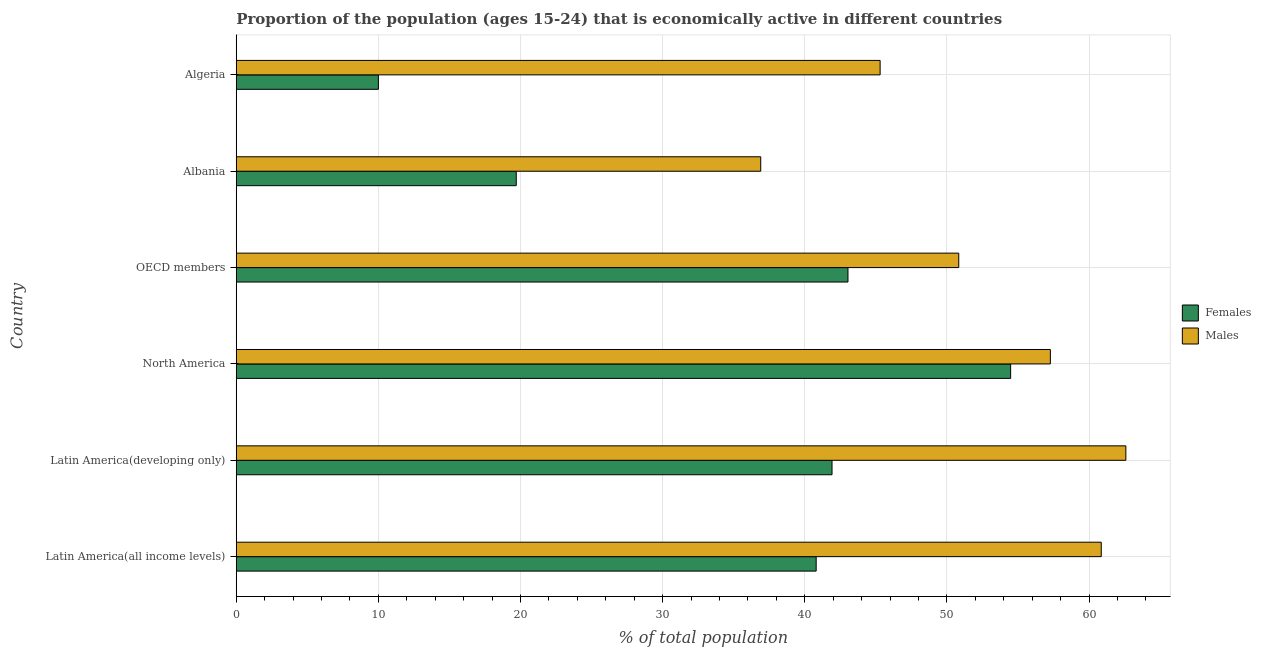How many different coloured bars are there?
Your answer should be very brief. 2. Are the number of bars per tick equal to the number of legend labels?
Your answer should be compact. Yes. How many bars are there on the 4th tick from the top?
Keep it short and to the point. 2. What is the label of the 6th group of bars from the top?
Make the answer very short. Latin America(all income levels). In how many cases, is the number of bars for a given country not equal to the number of legend labels?
Your answer should be compact. 0. What is the percentage of economically active female population in Latin America(developing only)?
Make the answer very short. 41.92. Across all countries, what is the maximum percentage of economically active female population?
Keep it short and to the point. 54.48. Across all countries, what is the minimum percentage of economically active female population?
Keep it short and to the point. 10. In which country was the percentage of economically active female population minimum?
Give a very brief answer. Algeria. What is the total percentage of economically active male population in the graph?
Offer a terse response. 313.76. What is the difference between the percentage of economically active female population in Algeria and that in OECD members?
Your answer should be compact. -33.04. What is the difference between the percentage of economically active male population in Latin America(developing only) and the percentage of economically active female population in North America?
Your answer should be very brief. 8.11. What is the average percentage of economically active female population per country?
Give a very brief answer. 34.99. What is the difference between the percentage of economically active female population and percentage of economically active male population in Latin America(all income levels)?
Make the answer very short. -20.06. What is the ratio of the percentage of economically active male population in Latin America(all income levels) to that in OECD members?
Keep it short and to the point. 1.2. Is the percentage of economically active male population in North America less than that in OECD members?
Your answer should be compact. No. What is the difference between the highest and the second highest percentage of economically active female population?
Offer a very short reply. 11.45. What is the difference between the highest and the lowest percentage of economically active female population?
Ensure brevity in your answer.  44.48. What does the 1st bar from the top in North America represents?
Your answer should be compact. Males. What does the 1st bar from the bottom in OECD members represents?
Keep it short and to the point. Females. Are all the bars in the graph horizontal?
Offer a terse response. Yes. What is the difference between two consecutive major ticks on the X-axis?
Your response must be concise. 10. Does the graph contain any zero values?
Your response must be concise. No. How many legend labels are there?
Provide a short and direct response. 2. How are the legend labels stacked?
Make the answer very short. Vertical. What is the title of the graph?
Offer a very short reply. Proportion of the population (ages 15-24) that is economically active in different countries. Does "US$" appear as one of the legend labels in the graph?
Your answer should be very brief. No. What is the label or title of the X-axis?
Provide a short and direct response. % of total population. What is the label or title of the Y-axis?
Make the answer very short. Country. What is the % of total population in Females in Latin America(all income levels)?
Offer a very short reply. 40.8. What is the % of total population of Males in Latin America(all income levels)?
Your response must be concise. 60.86. What is the % of total population in Females in Latin America(developing only)?
Make the answer very short. 41.92. What is the % of total population in Males in Latin America(developing only)?
Make the answer very short. 62.59. What is the % of total population in Females in North America?
Your answer should be very brief. 54.48. What is the % of total population in Males in North America?
Give a very brief answer. 57.28. What is the % of total population of Females in OECD members?
Your answer should be very brief. 43.04. What is the % of total population of Males in OECD members?
Your response must be concise. 50.83. What is the % of total population in Females in Albania?
Make the answer very short. 19.7. What is the % of total population in Males in Albania?
Your response must be concise. 36.9. What is the % of total population in Males in Algeria?
Give a very brief answer. 45.3. Across all countries, what is the maximum % of total population in Females?
Your response must be concise. 54.48. Across all countries, what is the maximum % of total population of Males?
Your answer should be compact. 62.59. Across all countries, what is the minimum % of total population of Females?
Keep it short and to the point. 10. Across all countries, what is the minimum % of total population of Males?
Provide a short and direct response. 36.9. What is the total % of total population in Females in the graph?
Keep it short and to the point. 209.94. What is the total % of total population in Males in the graph?
Your answer should be very brief. 313.76. What is the difference between the % of total population in Females in Latin America(all income levels) and that in Latin America(developing only)?
Provide a succinct answer. -1.12. What is the difference between the % of total population in Males in Latin America(all income levels) and that in Latin America(developing only)?
Provide a succinct answer. -1.73. What is the difference between the % of total population of Females in Latin America(all income levels) and that in North America?
Make the answer very short. -13.68. What is the difference between the % of total population of Males in Latin America(all income levels) and that in North America?
Your answer should be very brief. 3.58. What is the difference between the % of total population in Females in Latin America(all income levels) and that in OECD members?
Offer a very short reply. -2.24. What is the difference between the % of total population of Males in Latin America(all income levels) and that in OECD members?
Your answer should be compact. 10.03. What is the difference between the % of total population in Females in Latin America(all income levels) and that in Albania?
Keep it short and to the point. 21.1. What is the difference between the % of total population in Males in Latin America(all income levels) and that in Albania?
Keep it short and to the point. 23.96. What is the difference between the % of total population in Females in Latin America(all income levels) and that in Algeria?
Make the answer very short. 30.8. What is the difference between the % of total population in Males in Latin America(all income levels) and that in Algeria?
Provide a short and direct response. 15.56. What is the difference between the % of total population of Females in Latin America(developing only) and that in North America?
Your answer should be very brief. -12.57. What is the difference between the % of total population in Males in Latin America(developing only) and that in North America?
Make the answer very short. 5.31. What is the difference between the % of total population of Females in Latin America(developing only) and that in OECD members?
Your response must be concise. -1.12. What is the difference between the % of total population of Males in Latin America(developing only) and that in OECD members?
Provide a succinct answer. 11.76. What is the difference between the % of total population in Females in Latin America(developing only) and that in Albania?
Keep it short and to the point. 22.22. What is the difference between the % of total population of Males in Latin America(developing only) and that in Albania?
Your answer should be compact. 25.69. What is the difference between the % of total population in Females in Latin America(developing only) and that in Algeria?
Provide a short and direct response. 31.92. What is the difference between the % of total population of Males in Latin America(developing only) and that in Algeria?
Your answer should be compact. 17.29. What is the difference between the % of total population of Females in North America and that in OECD members?
Keep it short and to the point. 11.45. What is the difference between the % of total population of Males in North America and that in OECD members?
Keep it short and to the point. 6.45. What is the difference between the % of total population of Females in North America and that in Albania?
Keep it short and to the point. 34.78. What is the difference between the % of total population in Males in North America and that in Albania?
Provide a short and direct response. 20.38. What is the difference between the % of total population of Females in North America and that in Algeria?
Make the answer very short. 44.48. What is the difference between the % of total population in Males in North America and that in Algeria?
Ensure brevity in your answer.  11.98. What is the difference between the % of total population in Females in OECD members and that in Albania?
Give a very brief answer. 23.34. What is the difference between the % of total population of Males in OECD members and that in Albania?
Your answer should be compact. 13.93. What is the difference between the % of total population of Females in OECD members and that in Algeria?
Ensure brevity in your answer.  33.04. What is the difference between the % of total population in Males in OECD members and that in Algeria?
Offer a terse response. 5.53. What is the difference between the % of total population of Females in Albania and that in Algeria?
Provide a short and direct response. 9.7. What is the difference between the % of total population in Males in Albania and that in Algeria?
Keep it short and to the point. -8.4. What is the difference between the % of total population of Females in Latin America(all income levels) and the % of total population of Males in Latin America(developing only)?
Your answer should be very brief. -21.79. What is the difference between the % of total population in Females in Latin America(all income levels) and the % of total population in Males in North America?
Your answer should be very brief. -16.48. What is the difference between the % of total population of Females in Latin America(all income levels) and the % of total population of Males in OECD members?
Offer a very short reply. -10.03. What is the difference between the % of total population of Females in Latin America(all income levels) and the % of total population of Males in Albania?
Make the answer very short. 3.9. What is the difference between the % of total population of Females in Latin America(all income levels) and the % of total population of Males in Algeria?
Keep it short and to the point. -4.5. What is the difference between the % of total population in Females in Latin America(developing only) and the % of total population in Males in North America?
Offer a very short reply. -15.36. What is the difference between the % of total population in Females in Latin America(developing only) and the % of total population in Males in OECD members?
Keep it short and to the point. -8.92. What is the difference between the % of total population in Females in Latin America(developing only) and the % of total population in Males in Albania?
Your response must be concise. 5.02. What is the difference between the % of total population in Females in Latin America(developing only) and the % of total population in Males in Algeria?
Keep it short and to the point. -3.38. What is the difference between the % of total population of Females in North America and the % of total population of Males in OECD members?
Your answer should be very brief. 3.65. What is the difference between the % of total population of Females in North America and the % of total population of Males in Albania?
Ensure brevity in your answer.  17.58. What is the difference between the % of total population of Females in North America and the % of total population of Males in Algeria?
Your answer should be compact. 9.18. What is the difference between the % of total population of Females in OECD members and the % of total population of Males in Albania?
Provide a short and direct response. 6.14. What is the difference between the % of total population of Females in OECD members and the % of total population of Males in Algeria?
Your answer should be very brief. -2.26. What is the difference between the % of total population in Females in Albania and the % of total population in Males in Algeria?
Your answer should be compact. -25.6. What is the average % of total population in Females per country?
Provide a short and direct response. 34.99. What is the average % of total population of Males per country?
Offer a terse response. 52.29. What is the difference between the % of total population in Females and % of total population in Males in Latin America(all income levels)?
Your answer should be compact. -20.06. What is the difference between the % of total population of Females and % of total population of Males in Latin America(developing only)?
Ensure brevity in your answer.  -20.67. What is the difference between the % of total population of Females and % of total population of Males in North America?
Ensure brevity in your answer.  -2.79. What is the difference between the % of total population of Females and % of total population of Males in OECD members?
Keep it short and to the point. -7.79. What is the difference between the % of total population of Females and % of total population of Males in Albania?
Provide a succinct answer. -17.2. What is the difference between the % of total population in Females and % of total population in Males in Algeria?
Offer a terse response. -35.3. What is the ratio of the % of total population of Females in Latin America(all income levels) to that in Latin America(developing only)?
Offer a terse response. 0.97. What is the ratio of the % of total population in Males in Latin America(all income levels) to that in Latin America(developing only)?
Offer a very short reply. 0.97. What is the ratio of the % of total population of Females in Latin America(all income levels) to that in North America?
Make the answer very short. 0.75. What is the ratio of the % of total population of Males in Latin America(all income levels) to that in North America?
Provide a succinct answer. 1.06. What is the ratio of the % of total population of Females in Latin America(all income levels) to that in OECD members?
Give a very brief answer. 0.95. What is the ratio of the % of total population in Males in Latin America(all income levels) to that in OECD members?
Provide a short and direct response. 1.2. What is the ratio of the % of total population in Females in Latin America(all income levels) to that in Albania?
Offer a very short reply. 2.07. What is the ratio of the % of total population in Males in Latin America(all income levels) to that in Albania?
Provide a short and direct response. 1.65. What is the ratio of the % of total population in Females in Latin America(all income levels) to that in Algeria?
Provide a short and direct response. 4.08. What is the ratio of the % of total population of Males in Latin America(all income levels) to that in Algeria?
Give a very brief answer. 1.34. What is the ratio of the % of total population of Females in Latin America(developing only) to that in North America?
Give a very brief answer. 0.77. What is the ratio of the % of total population in Males in Latin America(developing only) to that in North America?
Give a very brief answer. 1.09. What is the ratio of the % of total population in Females in Latin America(developing only) to that in OECD members?
Your answer should be compact. 0.97. What is the ratio of the % of total population in Males in Latin America(developing only) to that in OECD members?
Your answer should be compact. 1.23. What is the ratio of the % of total population of Females in Latin America(developing only) to that in Albania?
Ensure brevity in your answer.  2.13. What is the ratio of the % of total population in Males in Latin America(developing only) to that in Albania?
Offer a very short reply. 1.7. What is the ratio of the % of total population of Females in Latin America(developing only) to that in Algeria?
Your answer should be very brief. 4.19. What is the ratio of the % of total population in Males in Latin America(developing only) to that in Algeria?
Give a very brief answer. 1.38. What is the ratio of the % of total population of Females in North America to that in OECD members?
Your response must be concise. 1.27. What is the ratio of the % of total population of Males in North America to that in OECD members?
Your answer should be very brief. 1.13. What is the ratio of the % of total population of Females in North America to that in Albania?
Ensure brevity in your answer.  2.77. What is the ratio of the % of total population in Males in North America to that in Albania?
Provide a succinct answer. 1.55. What is the ratio of the % of total population of Females in North America to that in Algeria?
Offer a very short reply. 5.45. What is the ratio of the % of total population in Males in North America to that in Algeria?
Offer a terse response. 1.26. What is the ratio of the % of total population of Females in OECD members to that in Albania?
Keep it short and to the point. 2.18. What is the ratio of the % of total population of Males in OECD members to that in Albania?
Offer a very short reply. 1.38. What is the ratio of the % of total population in Females in OECD members to that in Algeria?
Give a very brief answer. 4.3. What is the ratio of the % of total population in Males in OECD members to that in Algeria?
Give a very brief answer. 1.12. What is the ratio of the % of total population in Females in Albania to that in Algeria?
Keep it short and to the point. 1.97. What is the ratio of the % of total population in Males in Albania to that in Algeria?
Ensure brevity in your answer.  0.81. What is the difference between the highest and the second highest % of total population of Females?
Offer a very short reply. 11.45. What is the difference between the highest and the second highest % of total population of Males?
Offer a terse response. 1.73. What is the difference between the highest and the lowest % of total population of Females?
Your response must be concise. 44.48. What is the difference between the highest and the lowest % of total population in Males?
Your response must be concise. 25.69. 